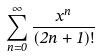<formula> <loc_0><loc_0><loc_500><loc_500>\sum _ { n = 0 } ^ { \infty } \frac { x ^ { n } } { ( 2 n + 1 ) ! }</formula> 